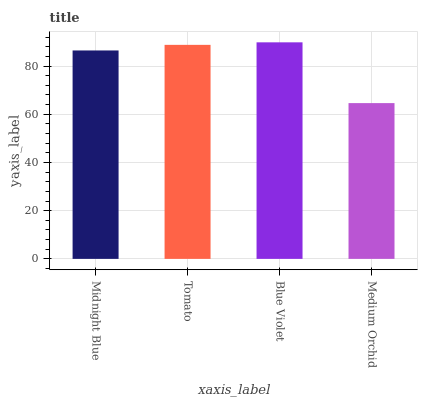Is Medium Orchid the minimum?
Answer yes or no. Yes. Is Blue Violet the maximum?
Answer yes or no. Yes. Is Tomato the minimum?
Answer yes or no. No. Is Tomato the maximum?
Answer yes or no. No. Is Tomato greater than Midnight Blue?
Answer yes or no. Yes. Is Midnight Blue less than Tomato?
Answer yes or no. Yes. Is Midnight Blue greater than Tomato?
Answer yes or no. No. Is Tomato less than Midnight Blue?
Answer yes or no. No. Is Tomato the high median?
Answer yes or no. Yes. Is Midnight Blue the low median?
Answer yes or no. Yes. Is Blue Violet the high median?
Answer yes or no. No. Is Tomato the low median?
Answer yes or no. No. 